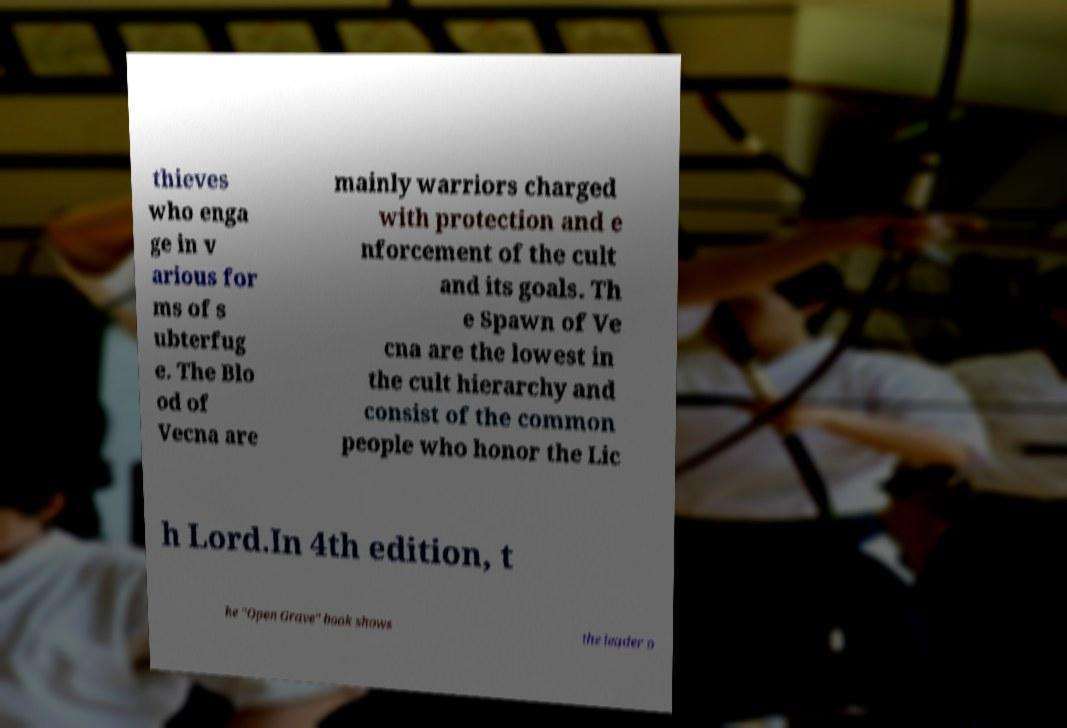There's text embedded in this image that I need extracted. Can you transcribe it verbatim? thieves who enga ge in v arious for ms of s ubterfug e. The Blo od of Vecna are mainly warriors charged with protection and e nforcement of the cult and its goals. Th e Spawn of Ve cna are the lowest in the cult hierarchy and consist of the common people who honor the Lic h Lord.In 4th edition, t he "Open Grave" book shows the leader o 